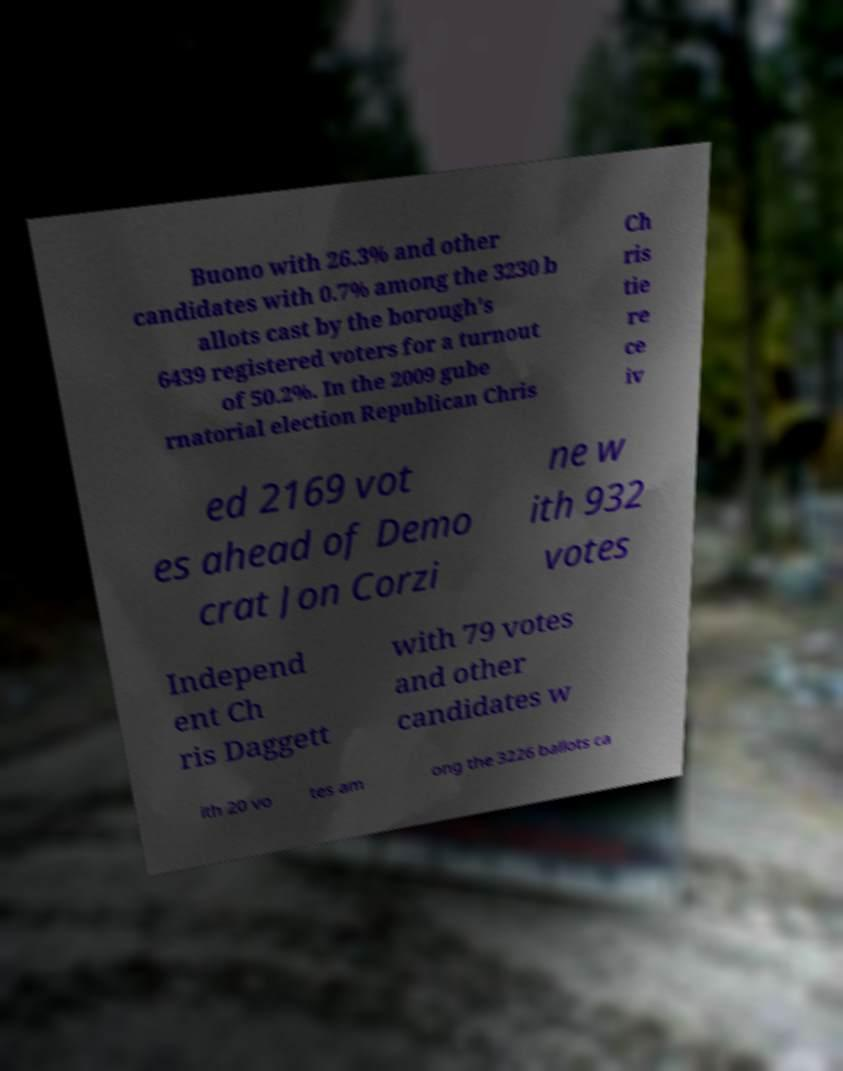There's text embedded in this image that I need extracted. Can you transcribe it verbatim? Buono with 26.3% and other candidates with 0.7% among the 3230 b allots cast by the borough's 6439 registered voters for a turnout of 50.2%. In the 2009 gube rnatorial election Republican Chris Ch ris tie re ce iv ed 2169 vot es ahead of Demo crat Jon Corzi ne w ith 932 votes Independ ent Ch ris Daggett with 79 votes and other candidates w ith 20 vo tes am ong the 3226 ballots ca 